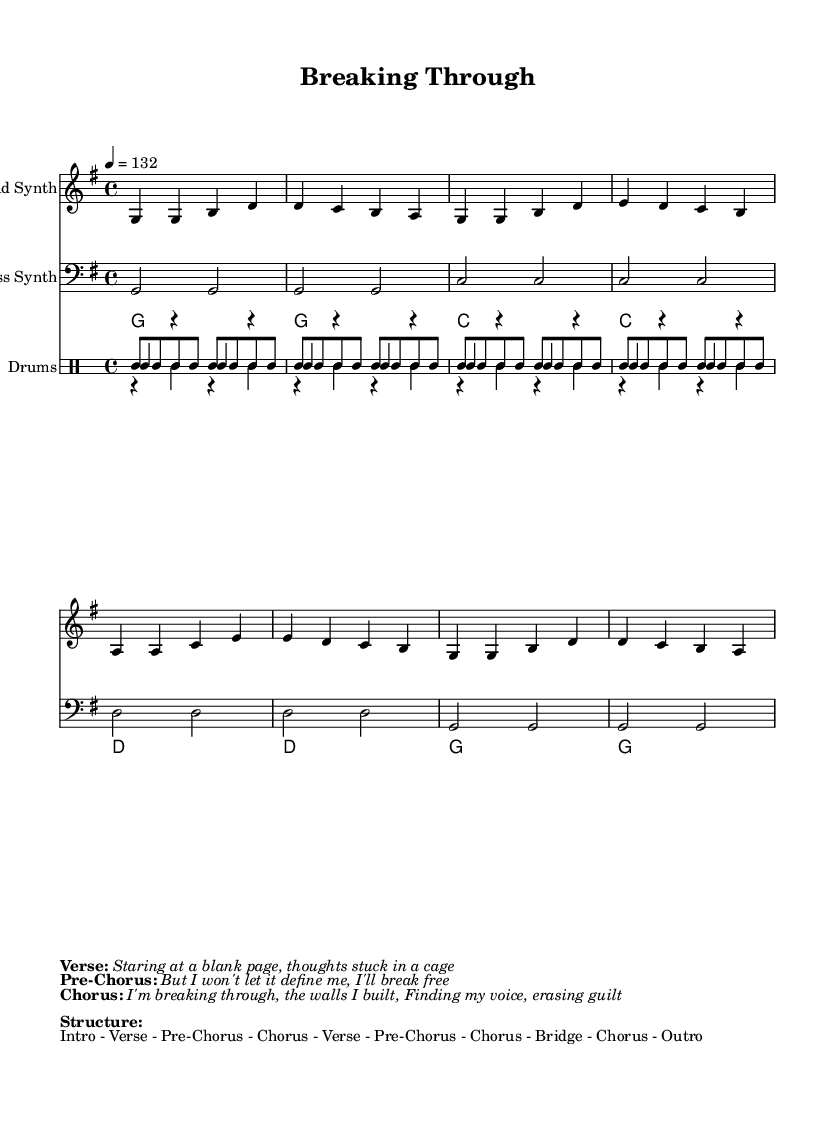What is the key signature of this music? The key signature is G major, which has one sharp (F#). This can be determined by looking for the key signature symbol located at the beginning of the staff.
Answer: G major What is the time signature of the piece? The time signature is 4/4, which indicates that there are four beats in each measure and a quarter note receives one beat. This is seen at the beginning of the score next to the key signature.
Answer: 4/4 What is the tempo marking for the track? The tempo marking is 132 beats per minute, indicated by the "4 = 132" notation. This tells musicians how fast to perform the piece.
Answer: 132 How many sections are there in the song structure? The song structure includes 10 sections as listed in the "Structure" markup. These are outlined in the formatted text at the bottom of the score.
Answer: 10 What is the main theme of the lyrics provided? The main theme revolves around overcoming obstacles, particularly related to creative blocks and self-doubt, as indicated by the phrases "breaking through" and "finding my voice" in the lyrics.
Answer: Overcoming obstacles What is the instrument used for the lead synth? The lead synth is performed on a synthesizer, as indicated by the staff header and the specific musical line for "Lead Synth". This contributes to the electronic sound characteristic of synth-pop music.
Answer: Lead Synth What is the meter for the drum patterns used in the piece? The drum patterns follow a 4/4 meter, which corresponds with the time signature of the piece, allowing for consistent rhythmic structure across all the percussion parts depicted.
Answer: 4/4 